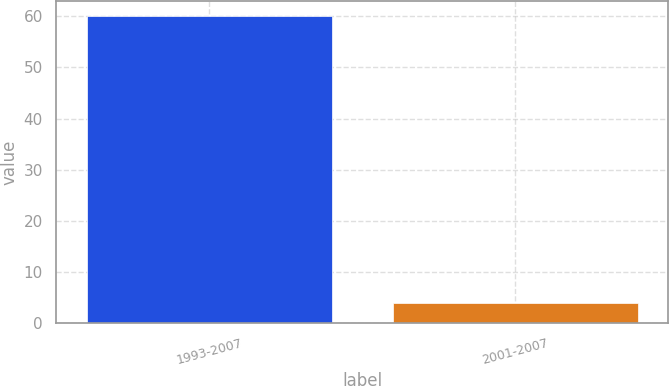Convert chart. <chart><loc_0><loc_0><loc_500><loc_500><bar_chart><fcel>1993-2007<fcel>2001-2007<nl><fcel>60<fcel>4<nl></chart> 